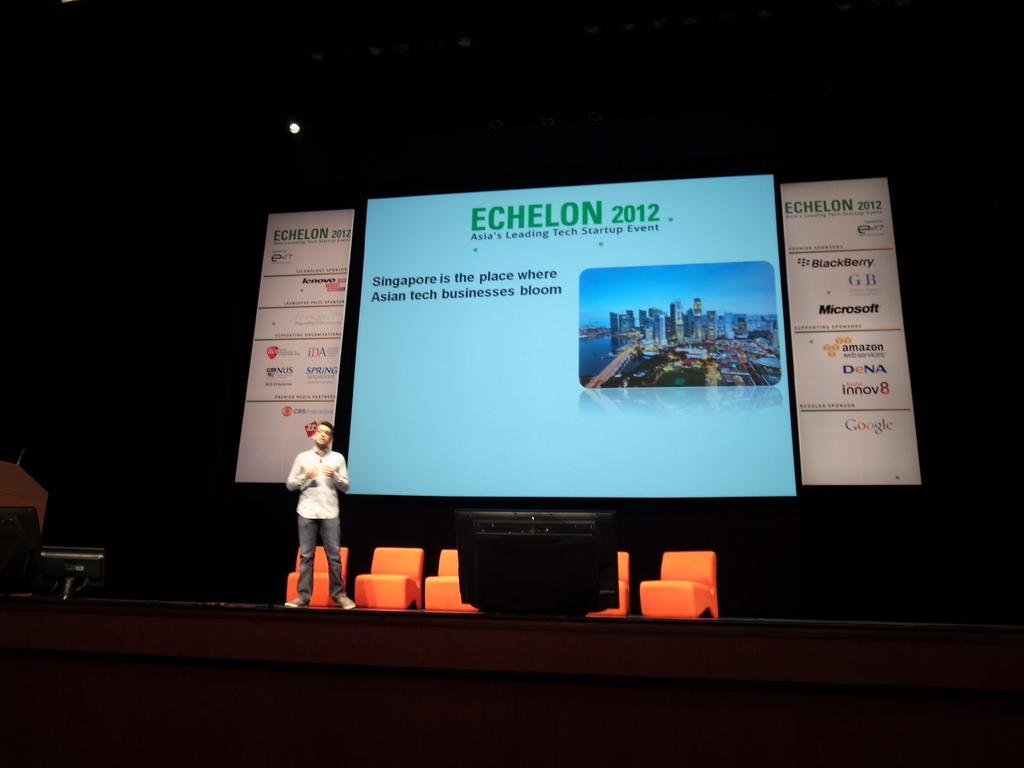Provide a one-sentence caption for the provided image. a lit up conference screen reading Echelon 2012. 